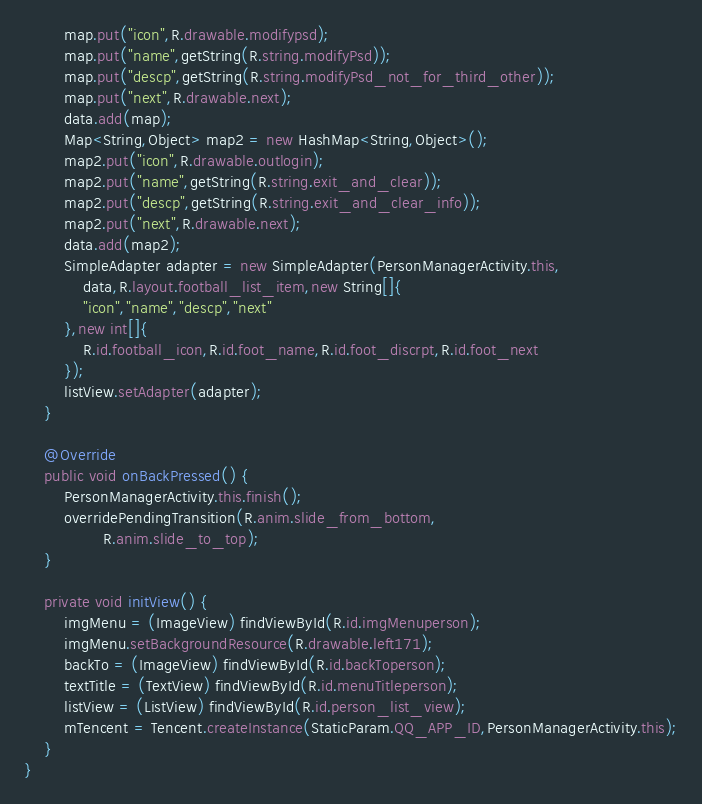<code> <loc_0><loc_0><loc_500><loc_500><_Java_>		map.put("icon",R.drawable.modifypsd);
		map.put("name",getString(R.string.modifyPsd));
		map.put("descp",getString(R.string.modifyPsd_not_for_third_other));
		map.put("next",R.drawable.next);
		data.add(map);
		Map<String,Object> map2 = new HashMap<String,Object>();
		map2.put("icon",R.drawable.outlogin);
		map2.put("name",getString(R.string.exit_and_clear));
		map2.put("descp",getString(R.string.exit_and_clear_info));
		map2.put("next",R.drawable.next);
		data.add(map2);
		SimpleAdapter adapter = new SimpleAdapter(PersonManagerActivity.this,
			data,R.layout.football_list_item,new String[]{
			"icon","name","descp","next"	
		},new int[]{
			R.id.football_icon,R.id.foot_name,R.id.foot_discrpt,R.id.foot_next	
		});
		listView.setAdapter(adapter);
	}

	@Override
	public void onBackPressed() {
		PersonManagerActivity.this.finish();
		overridePendingTransition(R.anim.slide_from_bottom,
				R.anim.slide_to_top);
	}
	
	private void initView() {
		imgMenu = (ImageView) findViewById(R.id.imgMenuperson);
		imgMenu.setBackgroundResource(R.drawable.left171);
		backTo = (ImageView) findViewById(R.id.backToperson);
		textTitle = (TextView) findViewById(R.id.menuTitleperson);
		listView = (ListView) findViewById(R.id.person_list_view);
		mTencent = Tencent.createInstance(StaticParam.QQ_APP_ID,PersonManagerActivity.this);
	}
}
</code> 